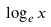Convert formula to latex. <formula><loc_0><loc_0><loc_500><loc_500>\log _ { e } x</formula> 